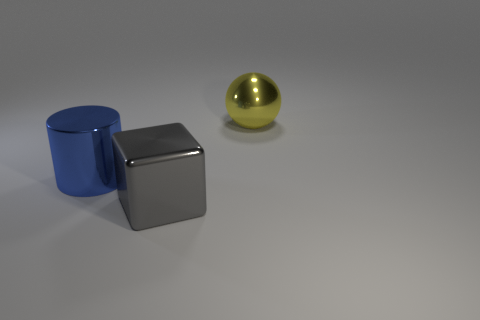The object that is behind the cube and on the left side of the ball is what color?
Your answer should be compact. Blue. What is the large object that is right of the big metallic thing in front of the metallic cylinder made of?
Make the answer very short. Metal. Are there an equal number of large yellow spheres and large red metal things?
Ensure brevity in your answer.  No. Do the big metallic thing behind the cylinder and the metal cube have the same color?
Offer a very short reply. No. Is the number of big gray rubber balls less than the number of big yellow shiny balls?
Offer a very short reply. Yes. How many other objects are the same color as the large metal cube?
Make the answer very short. 0. Does the thing that is behind the blue metallic object have the same material as the big cube?
Offer a terse response. Yes. What material is the large thing behind the blue metal cylinder?
Offer a terse response. Metal. There is a object on the left side of the big metal object in front of the blue cylinder; what is its size?
Your answer should be compact. Large. Is there a big gray block made of the same material as the large ball?
Provide a succinct answer. Yes. 